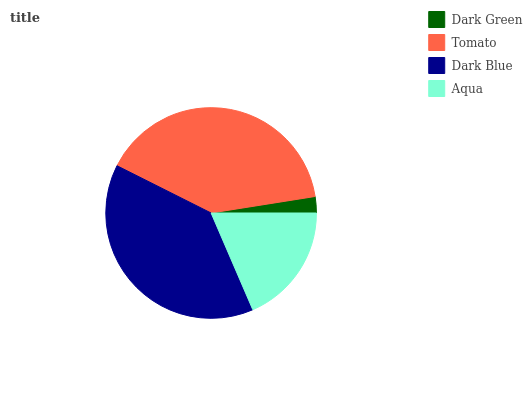Is Dark Green the minimum?
Answer yes or no. Yes. Is Tomato the maximum?
Answer yes or no. Yes. Is Dark Blue the minimum?
Answer yes or no. No. Is Dark Blue the maximum?
Answer yes or no. No. Is Tomato greater than Dark Blue?
Answer yes or no. Yes. Is Dark Blue less than Tomato?
Answer yes or no. Yes. Is Dark Blue greater than Tomato?
Answer yes or no. No. Is Tomato less than Dark Blue?
Answer yes or no. No. Is Dark Blue the high median?
Answer yes or no. Yes. Is Aqua the low median?
Answer yes or no. Yes. Is Aqua the high median?
Answer yes or no. No. Is Dark Green the low median?
Answer yes or no. No. 